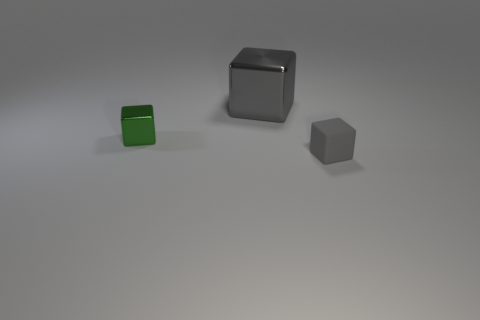Add 3 gray rubber blocks. How many objects exist? 6 Add 1 small gray matte blocks. How many small gray matte blocks are left? 2 Add 2 gray shiny things. How many gray shiny things exist? 3 Subtract 0 brown cubes. How many objects are left? 3 Subtract all small cyan cubes. Subtract all tiny objects. How many objects are left? 1 